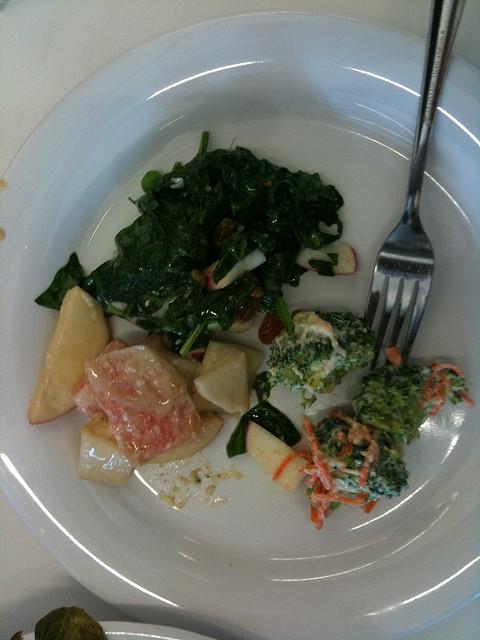Are there more than one vegetables on the plate?
Keep it brief. Yes. What utensil is on the plate?
Quick response, please. Fork. What is made from metal?
Give a very brief answer. Fork. 